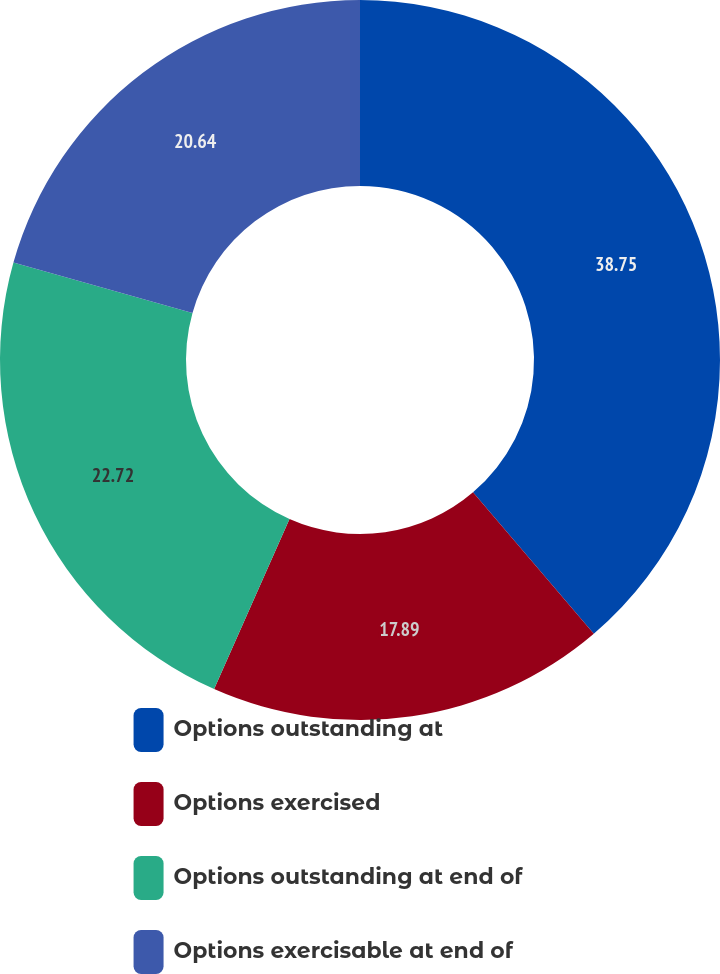Convert chart to OTSL. <chart><loc_0><loc_0><loc_500><loc_500><pie_chart><fcel>Options outstanding at<fcel>Options exercised<fcel>Options outstanding at end of<fcel>Options exercisable at end of<nl><fcel>38.75%<fcel>17.89%<fcel>22.72%<fcel>20.64%<nl></chart> 